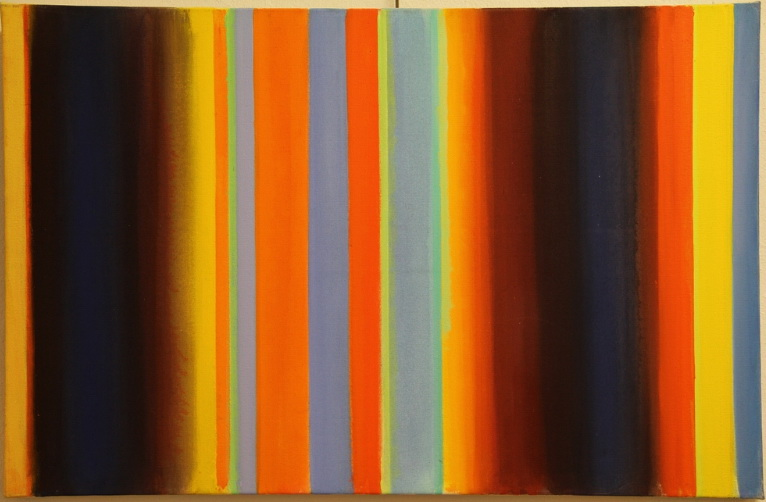How might this painting be related to the historical context of the time it was created? Considering the stylistic elements reminiscent of the mid-20th century, this painting likely reflects the historical and cultural movements of that period, such as the rise of abstract expressionism. This art movement was characterized by an emphasis on bold, abstract forms and was part of a larger post-war movement towards expressing individuality and emotional depth devoid of traditional forms. The painting may also echo the societal shifts towards modernism and a break from conventional norms, symbolizing a new era of artistic exploration and expression. 